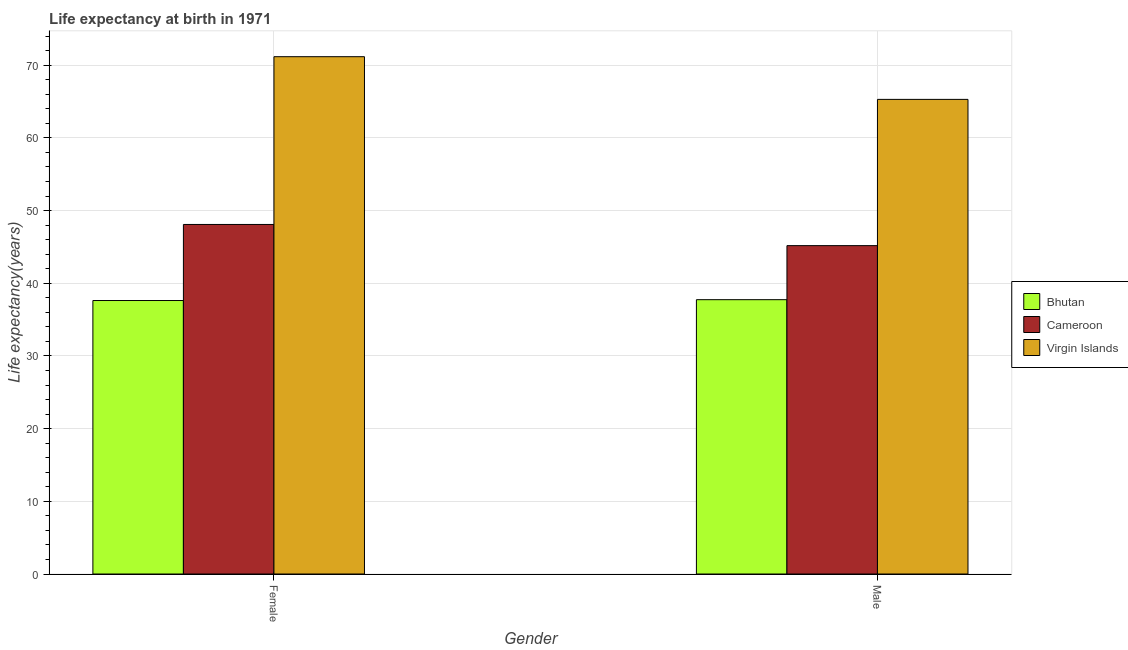Are the number of bars on each tick of the X-axis equal?
Your response must be concise. Yes. How many bars are there on the 2nd tick from the right?
Ensure brevity in your answer.  3. What is the life expectancy(female) in Bhutan?
Your answer should be very brief. 37.62. Across all countries, what is the maximum life expectancy(male)?
Offer a terse response. 65.3. Across all countries, what is the minimum life expectancy(male)?
Offer a terse response. 37.74. In which country was the life expectancy(male) maximum?
Provide a short and direct response. Virgin Islands. In which country was the life expectancy(female) minimum?
Provide a succinct answer. Bhutan. What is the total life expectancy(female) in the graph?
Keep it short and to the point. 156.89. What is the difference between the life expectancy(female) in Virgin Islands and that in Bhutan?
Offer a very short reply. 33.55. What is the difference between the life expectancy(female) in Cameroon and the life expectancy(male) in Virgin Islands?
Give a very brief answer. -17.21. What is the average life expectancy(female) per country?
Provide a short and direct response. 52.3. What is the difference between the life expectancy(male) and life expectancy(female) in Cameroon?
Offer a very short reply. -2.91. In how many countries, is the life expectancy(male) greater than 52 years?
Offer a terse response. 1. What is the ratio of the life expectancy(female) in Virgin Islands to that in Bhutan?
Your answer should be compact. 1.89. Is the life expectancy(male) in Bhutan less than that in Cameroon?
Give a very brief answer. Yes. In how many countries, is the life expectancy(male) greater than the average life expectancy(male) taken over all countries?
Provide a short and direct response. 1. What does the 1st bar from the left in Male represents?
Give a very brief answer. Bhutan. What does the 3rd bar from the right in Female represents?
Keep it short and to the point. Bhutan. Are all the bars in the graph horizontal?
Ensure brevity in your answer.  No. How many countries are there in the graph?
Make the answer very short. 3. What is the difference between two consecutive major ticks on the Y-axis?
Offer a very short reply. 10. Does the graph contain any zero values?
Keep it short and to the point. No. What is the title of the graph?
Offer a very short reply. Life expectancy at birth in 1971. Does "Syrian Arab Republic" appear as one of the legend labels in the graph?
Ensure brevity in your answer.  No. What is the label or title of the Y-axis?
Provide a short and direct response. Life expectancy(years). What is the Life expectancy(years) of Bhutan in Female?
Ensure brevity in your answer.  37.62. What is the Life expectancy(years) in Cameroon in Female?
Your response must be concise. 48.09. What is the Life expectancy(years) of Virgin Islands in Female?
Make the answer very short. 71.17. What is the Life expectancy(years) of Bhutan in Male?
Offer a very short reply. 37.74. What is the Life expectancy(years) of Cameroon in Male?
Provide a short and direct response. 45.18. What is the Life expectancy(years) of Virgin Islands in Male?
Ensure brevity in your answer.  65.3. Across all Gender, what is the maximum Life expectancy(years) in Bhutan?
Offer a terse response. 37.74. Across all Gender, what is the maximum Life expectancy(years) of Cameroon?
Make the answer very short. 48.09. Across all Gender, what is the maximum Life expectancy(years) of Virgin Islands?
Keep it short and to the point. 71.17. Across all Gender, what is the minimum Life expectancy(years) in Bhutan?
Your answer should be very brief. 37.62. Across all Gender, what is the minimum Life expectancy(years) of Cameroon?
Your answer should be very brief. 45.18. Across all Gender, what is the minimum Life expectancy(years) of Virgin Islands?
Offer a terse response. 65.3. What is the total Life expectancy(years) in Bhutan in the graph?
Make the answer very short. 75.37. What is the total Life expectancy(years) of Cameroon in the graph?
Give a very brief answer. 93.27. What is the total Life expectancy(years) of Virgin Islands in the graph?
Your response must be concise. 136.47. What is the difference between the Life expectancy(years) in Bhutan in Female and that in Male?
Offer a very short reply. -0.12. What is the difference between the Life expectancy(years) of Cameroon in Female and that in Male?
Give a very brief answer. 2.91. What is the difference between the Life expectancy(years) of Virgin Islands in Female and that in Male?
Make the answer very short. 5.87. What is the difference between the Life expectancy(years) of Bhutan in Female and the Life expectancy(years) of Cameroon in Male?
Your answer should be compact. -7.55. What is the difference between the Life expectancy(years) of Bhutan in Female and the Life expectancy(years) of Virgin Islands in Male?
Offer a terse response. -27.68. What is the difference between the Life expectancy(years) in Cameroon in Female and the Life expectancy(years) in Virgin Islands in Male?
Your response must be concise. -17.21. What is the average Life expectancy(years) in Bhutan per Gender?
Make the answer very short. 37.68. What is the average Life expectancy(years) in Cameroon per Gender?
Your answer should be very brief. 46.63. What is the average Life expectancy(years) of Virgin Islands per Gender?
Your answer should be compact. 68.24. What is the difference between the Life expectancy(years) in Bhutan and Life expectancy(years) in Cameroon in Female?
Provide a short and direct response. -10.46. What is the difference between the Life expectancy(years) in Bhutan and Life expectancy(years) in Virgin Islands in Female?
Offer a very short reply. -33.55. What is the difference between the Life expectancy(years) in Cameroon and Life expectancy(years) in Virgin Islands in Female?
Keep it short and to the point. -23.08. What is the difference between the Life expectancy(years) of Bhutan and Life expectancy(years) of Cameroon in Male?
Make the answer very short. -7.44. What is the difference between the Life expectancy(years) of Bhutan and Life expectancy(years) of Virgin Islands in Male?
Ensure brevity in your answer.  -27.56. What is the difference between the Life expectancy(years) in Cameroon and Life expectancy(years) in Virgin Islands in Male?
Your answer should be very brief. -20.12. What is the ratio of the Life expectancy(years) in Bhutan in Female to that in Male?
Your answer should be compact. 1. What is the ratio of the Life expectancy(years) in Cameroon in Female to that in Male?
Provide a succinct answer. 1.06. What is the ratio of the Life expectancy(years) in Virgin Islands in Female to that in Male?
Offer a very short reply. 1.09. What is the difference between the highest and the second highest Life expectancy(years) in Bhutan?
Ensure brevity in your answer.  0.12. What is the difference between the highest and the second highest Life expectancy(years) of Cameroon?
Keep it short and to the point. 2.91. What is the difference between the highest and the second highest Life expectancy(years) in Virgin Islands?
Ensure brevity in your answer.  5.87. What is the difference between the highest and the lowest Life expectancy(years) of Bhutan?
Give a very brief answer. 0.12. What is the difference between the highest and the lowest Life expectancy(years) in Cameroon?
Keep it short and to the point. 2.91. What is the difference between the highest and the lowest Life expectancy(years) of Virgin Islands?
Your answer should be compact. 5.87. 